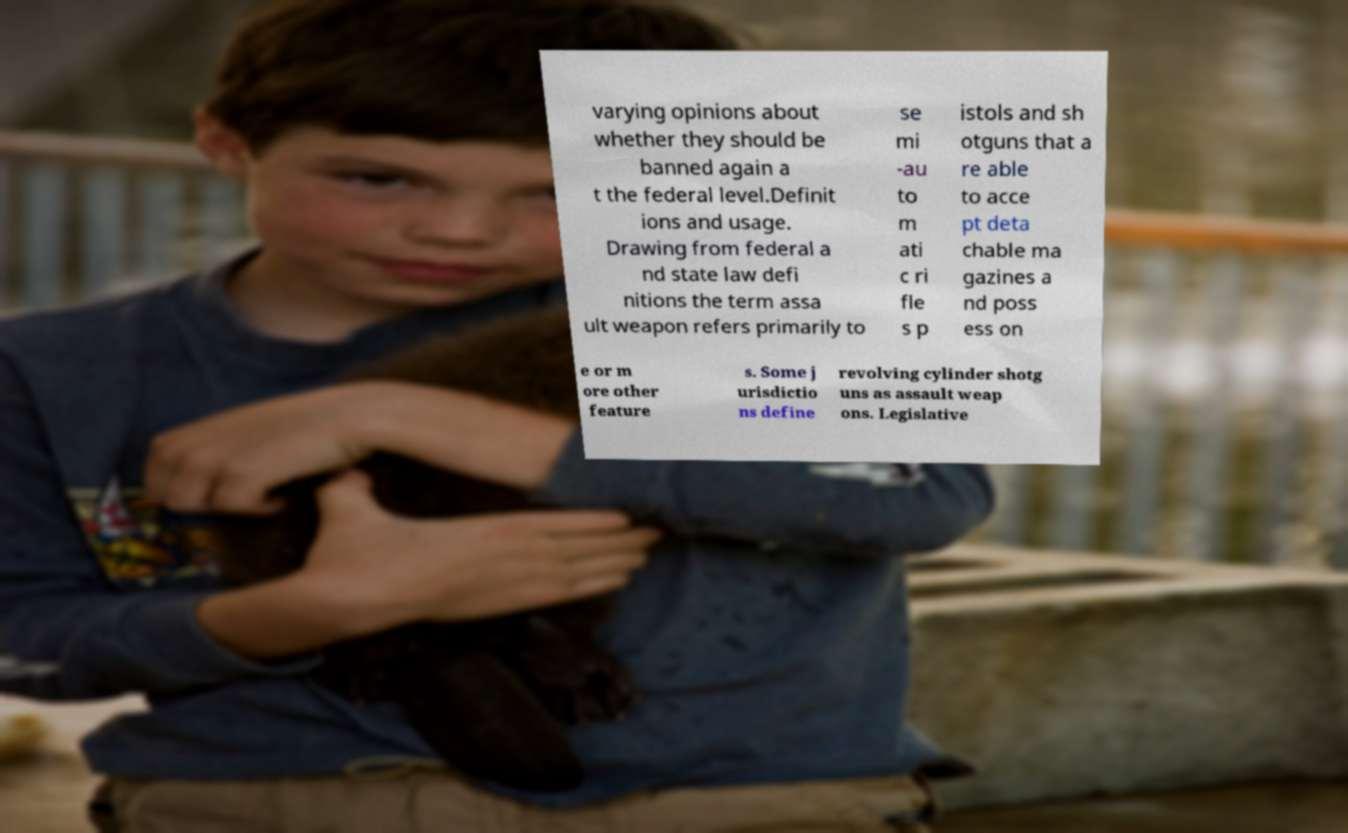Can you accurately transcribe the text from the provided image for me? varying opinions about whether they should be banned again a t the federal level.Definit ions and usage. Drawing from federal a nd state law defi nitions the term assa ult weapon refers primarily to se mi -au to m ati c ri fle s p istols and sh otguns that a re able to acce pt deta chable ma gazines a nd poss ess on e or m ore other feature s. Some j urisdictio ns define revolving cylinder shotg uns as assault weap ons. Legislative 